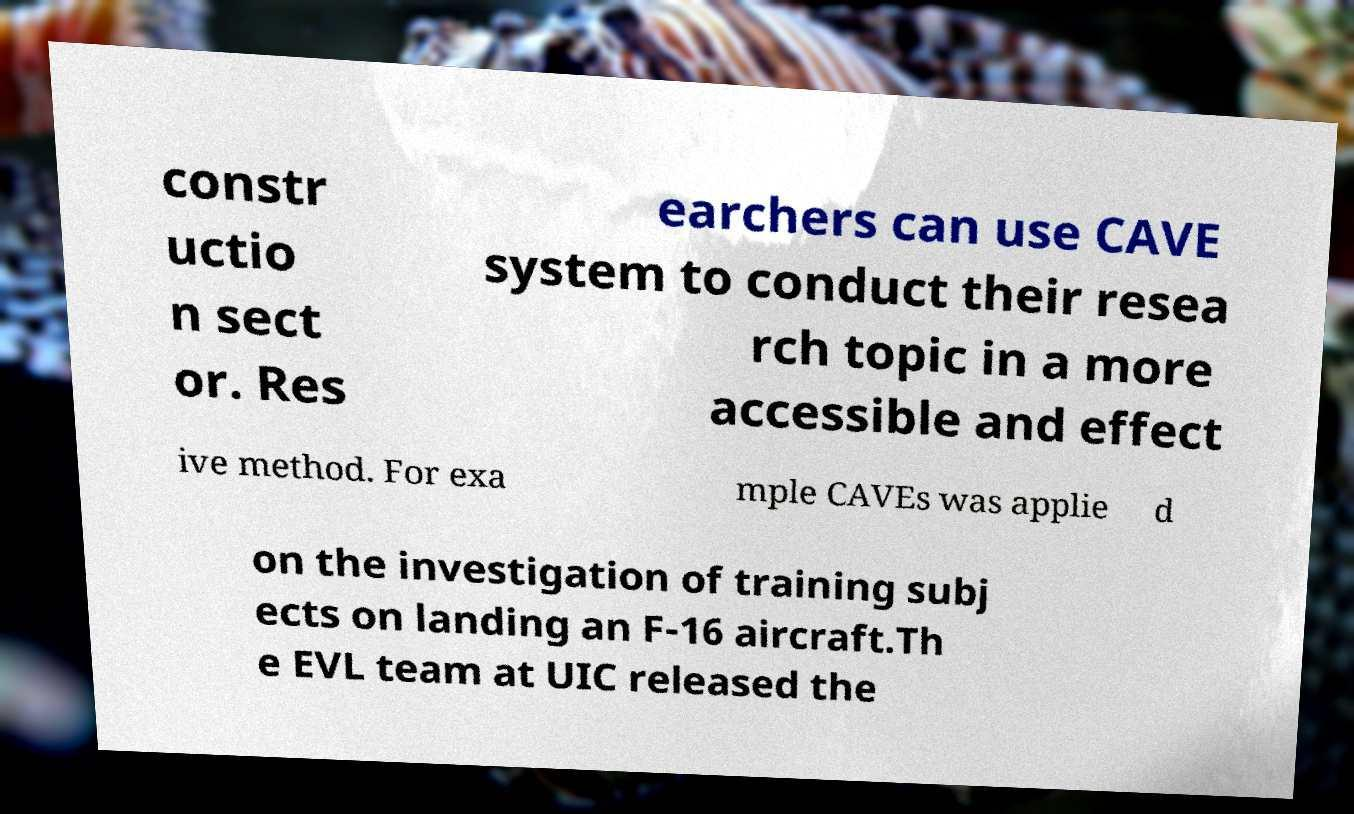I need the written content from this picture converted into text. Can you do that? constr uctio n sect or. Res earchers can use CAVE system to conduct their resea rch topic in a more accessible and effect ive method. For exa mple CAVEs was applie d on the investigation of training subj ects on landing an F-16 aircraft.Th e EVL team at UIC released the 